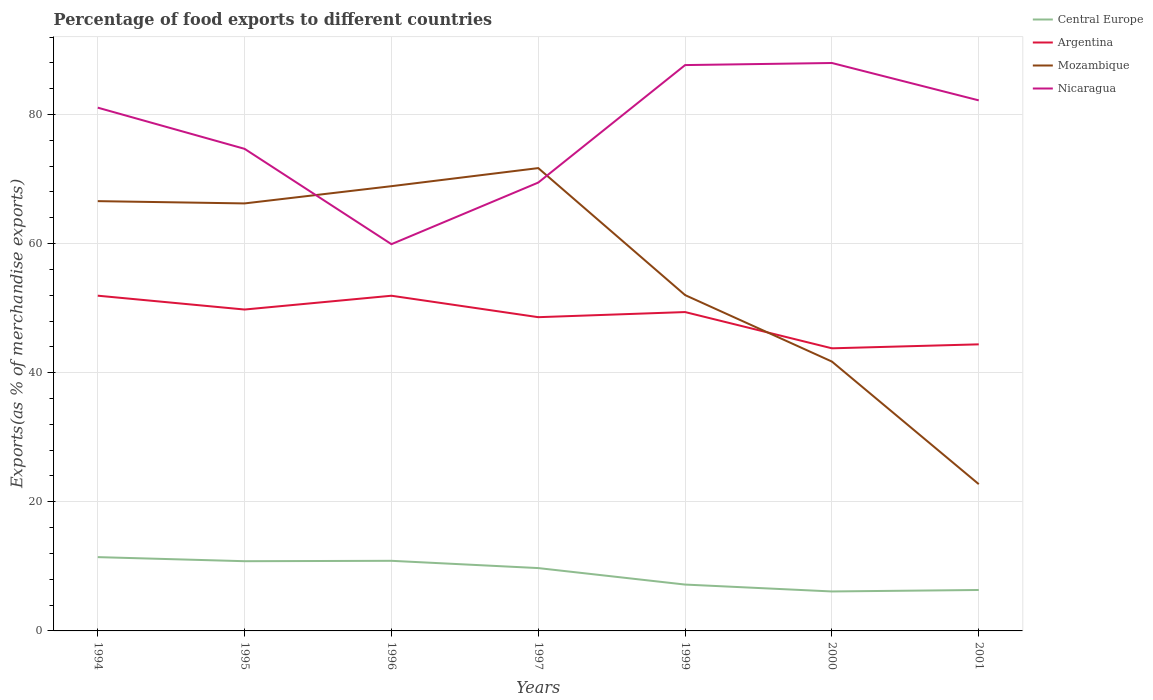How many different coloured lines are there?
Your answer should be very brief. 4. Across all years, what is the maximum percentage of exports to different countries in Mozambique?
Offer a very short reply. 22.73. In which year was the percentage of exports to different countries in Nicaragua maximum?
Offer a terse response. 1996. What is the total percentage of exports to different countries in Nicaragua in the graph?
Make the answer very short. -27.74. What is the difference between the highest and the second highest percentage of exports to different countries in Mozambique?
Your answer should be compact. 48.96. What is the difference between the highest and the lowest percentage of exports to different countries in Nicaragua?
Provide a succinct answer. 4. What is the difference between two consecutive major ticks on the Y-axis?
Ensure brevity in your answer.  20. Does the graph contain any zero values?
Keep it short and to the point. No. Does the graph contain grids?
Your answer should be compact. Yes. What is the title of the graph?
Offer a very short reply. Percentage of food exports to different countries. Does "Northern Mariana Islands" appear as one of the legend labels in the graph?
Ensure brevity in your answer.  No. What is the label or title of the Y-axis?
Offer a very short reply. Exports(as % of merchandise exports). What is the Exports(as % of merchandise exports) of Central Europe in 1994?
Your answer should be compact. 11.43. What is the Exports(as % of merchandise exports) in Argentina in 1994?
Keep it short and to the point. 51.93. What is the Exports(as % of merchandise exports) in Mozambique in 1994?
Offer a terse response. 66.58. What is the Exports(as % of merchandise exports) in Nicaragua in 1994?
Offer a very short reply. 81.06. What is the Exports(as % of merchandise exports) in Central Europe in 1995?
Provide a short and direct response. 10.8. What is the Exports(as % of merchandise exports) of Argentina in 1995?
Your response must be concise. 49.79. What is the Exports(as % of merchandise exports) in Mozambique in 1995?
Your response must be concise. 66.22. What is the Exports(as % of merchandise exports) in Nicaragua in 1995?
Offer a terse response. 74.68. What is the Exports(as % of merchandise exports) in Central Europe in 1996?
Give a very brief answer. 10.86. What is the Exports(as % of merchandise exports) in Argentina in 1996?
Make the answer very short. 51.92. What is the Exports(as % of merchandise exports) in Mozambique in 1996?
Ensure brevity in your answer.  68.89. What is the Exports(as % of merchandise exports) in Nicaragua in 1996?
Your answer should be compact. 59.91. What is the Exports(as % of merchandise exports) in Central Europe in 1997?
Your answer should be compact. 9.73. What is the Exports(as % of merchandise exports) of Argentina in 1997?
Your response must be concise. 48.6. What is the Exports(as % of merchandise exports) in Mozambique in 1997?
Make the answer very short. 71.69. What is the Exports(as % of merchandise exports) in Nicaragua in 1997?
Your answer should be very brief. 69.45. What is the Exports(as % of merchandise exports) in Central Europe in 1999?
Offer a terse response. 7.18. What is the Exports(as % of merchandise exports) of Argentina in 1999?
Provide a short and direct response. 49.39. What is the Exports(as % of merchandise exports) in Mozambique in 1999?
Your response must be concise. 52.02. What is the Exports(as % of merchandise exports) in Nicaragua in 1999?
Your answer should be very brief. 87.65. What is the Exports(as % of merchandise exports) of Central Europe in 2000?
Give a very brief answer. 6.11. What is the Exports(as % of merchandise exports) in Argentina in 2000?
Offer a very short reply. 43.78. What is the Exports(as % of merchandise exports) of Mozambique in 2000?
Keep it short and to the point. 41.72. What is the Exports(as % of merchandise exports) in Nicaragua in 2000?
Your response must be concise. 87.98. What is the Exports(as % of merchandise exports) in Central Europe in 2001?
Your answer should be compact. 6.34. What is the Exports(as % of merchandise exports) of Argentina in 2001?
Give a very brief answer. 44.39. What is the Exports(as % of merchandise exports) in Mozambique in 2001?
Your response must be concise. 22.73. What is the Exports(as % of merchandise exports) in Nicaragua in 2001?
Ensure brevity in your answer.  82.19. Across all years, what is the maximum Exports(as % of merchandise exports) in Central Europe?
Make the answer very short. 11.43. Across all years, what is the maximum Exports(as % of merchandise exports) of Argentina?
Make the answer very short. 51.93. Across all years, what is the maximum Exports(as % of merchandise exports) of Mozambique?
Your response must be concise. 71.69. Across all years, what is the maximum Exports(as % of merchandise exports) of Nicaragua?
Your response must be concise. 87.98. Across all years, what is the minimum Exports(as % of merchandise exports) in Central Europe?
Offer a terse response. 6.11. Across all years, what is the minimum Exports(as % of merchandise exports) of Argentina?
Provide a succinct answer. 43.78. Across all years, what is the minimum Exports(as % of merchandise exports) of Mozambique?
Your answer should be very brief. 22.73. Across all years, what is the minimum Exports(as % of merchandise exports) in Nicaragua?
Your answer should be compact. 59.91. What is the total Exports(as % of merchandise exports) in Central Europe in the graph?
Provide a short and direct response. 62.46. What is the total Exports(as % of merchandise exports) in Argentina in the graph?
Offer a very short reply. 339.8. What is the total Exports(as % of merchandise exports) in Mozambique in the graph?
Ensure brevity in your answer.  389.87. What is the total Exports(as % of merchandise exports) of Nicaragua in the graph?
Offer a very short reply. 542.91. What is the difference between the Exports(as % of merchandise exports) in Central Europe in 1994 and that in 1995?
Offer a terse response. 0.63. What is the difference between the Exports(as % of merchandise exports) in Argentina in 1994 and that in 1995?
Keep it short and to the point. 2.14. What is the difference between the Exports(as % of merchandise exports) in Mozambique in 1994 and that in 1995?
Your answer should be compact. 0.35. What is the difference between the Exports(as % of merchandise exports) in Nicaragua in 1994 and that in 1995?
Provide a succinct answer. 6.38. What is the difference between the Exports(as % of merchandise exports) in Central Europe in 1994 and that in 1996?
Provide a short and direct response. 0.57. What is the difference between the Exports(as % of merchandise exports) in Argentina in 1994 and that in 1996?
Your answer should be very brief. 0.01. What is the difference between the Exports(as % of merchandise exports) in Mozambique in 1994 and that in 1996?
Make the answer very short. -2.32. What is the difference between the Exports(as % of merchandise exports) in Nicaragua in 1994 and that in 1996?
Give a very brief answer. 21.15. What is the difference between the Exports(as % of merchandise exports) in Central Europe in 1994 and that in 1997?
Ensure brevity in your answer.  1.7. What is the difference between the Exports(as % of merchandise exports) of Argentina in 1994 and that in 1997?
Provide a short and direct response. 3.33. What is the difference between the Exports(as % of merchandise exports) in Mozambique in 1994 and that in 1997?
Provide a succinct answer. -5.12. What is the difference between the Exports(as % of merchandise exports) of Nicaragua in 1994 and that in 1997?
Offer a very short reply. 11.6. What is the difference between the Exports(as % of merchandise exports) of Central Europe in 1994 and that in 1999?
Provide a short and direct response. 4.25. What is the difference between the Exports(as % of merchandise exports) of Argentina in 1994 and that in 1999?
Provide a short and direct response. 2.54. What is the difference between the Exports(as % of merchandise exports) of Mozambique in 1994 and that in 1999?
Provide a succinct answer. 14.55. What is the difference between the Exports(as % of merchandise exports) of Nicaragua in 1994 and that in 1999?
Your answer should be compact. -6.6. What is the difference between the Exports(as % of merchandise exports) in Central Europe in 1994 and that in 2000?
Give a very brief answer. 5.32. What is the difference between the Exports(as % of merchandise exports) of Argentina in 1994 and that in 2000?
Ensure brevity in your answer.  8.15. What is the difference between the Exports(as % of merchandise exports) in Mozambique in 1994 and that in 2000?
Offer a very short reply. 24.85. What is the difference between the Exports(as % of merchandise exports) in Nicaragua in 1994 and that in 2000?
Offer a terse response. -6.92. What is the difference between the Exports(as % of merchandise exports) of Central Europe in 1994 and that in 2001?
Provide a succinct answer. 5.09. What is the difference between the Exports(as % of merchandise exports) of Argentina in 1994 and that in 2001?
Offer a terse response. 7.54. What is the difference between the Exports(as % of merchandise exports) of Mozambique in 1994 and that in 2001?
Offer a terse response. 43.84. What is the difference between the Exports(as % of merchandise exports) in Nicaragua in 1994 and that in 2001?
Your response must be concise. -1.13. What is the difference between the Exports(as % of merchandise exports) in Central Europe in 1995 and that in 1996?
Offer a very short reply. -0.06. What is the difference between the Exports(as % of merchandise exports) in Argentina in 1995 and that in 1996?
Provide a short and direct response. -2.14. What is the difference between the Exports(as % of merchandise exports) in Mozambique in 1995 and that in 1996?
Offer a terse response. -2.67. What is the difference between the Exports(as % of merchandise exports) in Nicaragua in 1995 and that in 1996?
Your answer should be very brief. 14.77. What is the difference between the Exports(as % of merchandise exports) in Central Europe in 1995 and that in 1997?
Give a very brief answer. 1.07. What is the difference between the Exports(as % of merchandise exports) in Argentina in 1995 and that in 1997?
Ensure brevity in your answer.  1.19. What is the difference between the Exports(as % of merchandise exports) of Mozambique in 1995 and that in 1997?
Offer a very short reply. -5.47. What is the difference between the Exports(as % of merchandise exports) in Nicaragua in 1995 and that in 1997?
Make the answer very short. 5.22. What is the difference between the Exports(as % of merchandise exports) in Central Europe in 1995 and that in 1999?
Provide a succinct answer. 3.62. What is the difference between the Exports(as % of merchandise exports) of Argentina in 1995 and that in 1999?
Keep it short and to the point. 0.39. What is the difference between the Exports(as % of merchandise exports) of Mozambique in 1995 and that in 1999?
Your answer should be compact. 14.2. What is the difference between the Exports(as % of merchandise exports) in Nicaragua in 1995 and that in 1999?
Your answer should be very brief. -12.98. What is the difference between the Exports(as % of merchandise exports) in Central Europe in 1995 and that in 2000?
Your response must be concise. 4.69. What is the difference between the Exports(as % of merchandise exports) in Argentina in 1995 and that in 2000?
Your response must be concise. 6.01. What is the difference between the Exports(as % of merchandise exports) of Mozambique in 1995 and that in 2000?
Your answer should be very brief. 24.5. What is the difference between the Exports(as % of merchandise exports) of Nicaragua in 1995 and that in 2000?
Offer a very short reply. -13.3. What is the difference between the Exports(as % of merchandise exports) of Central Europe in 1995 and that in 2001?
Your response must be concise. 4.46. What is the difference between the Exports(as % of merchandise exports) in Argentina in 1995 and that in 2001?
Give a very brief answer. 5.39. What is the difference between the Exports(as % of merchandise exports) of Mozambique in 1995 and that in 2001?
Ensure brevity in your answer.  43.49. What is the difference between the Exports(as % of merchandise exports) of Nicaragua in 1995 and that in 2001?
Keep it short and to the point. -7.51. What is the difference between the Exports(as % of merchandise exports) of Central Europe in 1996 and that in 1997?
Provide a short and direct response. 1.13. What is the difference between the Exports(as % of merchandise exports) in Argentina in 1996 and that in 1997?
Keep it short and to the point. 3.32. What is the difference between the Exports(as % of merchandise exports) of Mozambique in 1996 and that in 1997?
Offer a terse response. -2.8. What is the difference between the Exports(as % of merchandise exports) of Nicaragua in 1996 and that in 1997?
Keep it short and to the point. -9.54. What is the difference between the Exports(as % of merchandise exports) in Central Europe in 1996 and that in 1999?
Ensure brevity in your answer.  3.68. What is the difference between the Exports(as % of merchandise exports) in Argentina in 1996 and that in 1999?
Make the answer very short. 2.53. What is the difference between the Exports(as % of merchandise exports) of Mozambique in 1996 and that in 1999?
Give a very brief answer. 16.87. What is the difference between the Exports(as % of merchandise exports) in Nicaragua in 1996 and that in 1999?
Your response must be concise. -27.74. What is the difference between the Exports(as % of merchandise exports) of Central Europe in 1996 and that in 2000?
Provide a short and direct response. 4.75. What is the difference between the Exports(as % of merchandise exports) in Argentina in 1996 and that in 2000?
Provide a succinct answer. 8.14. What is the difference between the Exports(as % of merchandise exports) in Mozambique in 1996 and that in 2000?
Your response must be concise. 27.17. What is the difference between the Exports(as % of merchandise exports) in Nicaragua in 1996 and that in 2000?
Offer a very short reply. -28.07. What is the difference between the Exports(as % of merchandise exports) of Central Europe in 1996 and that in 2001?
Make the answer very short. 4.52. What is the difference between the Exports(as % of merchandise exports) of Argentina in 1996 and that in 2001?
Offer a terse response. 7.53. What is the difference between the Exports(as % of merchandise exports) of Mozambique in 1996 and that in 2001?
Keep it short and to the point. 46.16. What is the difference between the Exports(as % of merchandise exports) of Nicaragua in 1996 and that in 2001?
Ensure brevity in your answer.  -22.28. What is the difference between the Exports(as % of merchandise exports) in Central Europe in 1997 and that in 1999?
Ensure brevity in your answer.  2.55. What is the difference between the Exports(as % of merchandise exports) of Argentina in 1997 and that in 1999?
Your answer should be very brief. -0.79. What is the difference between the Exports(as % of merchandise exports) of Mozambique in 1997 and that in 1999?
Your answer should be very brief. 19.67. What is the difference between the Exports(as % of merchandise exports) of Nicaragua in 1997 and that in 1999?
Ensure brevity in your answer.  -18.2. What is the difference between the Exports(as % of merchandise exports) of Central Europe in 1997 and that in 2000?
Ensure brevity in your answer.  3.62. What is the difference between the Exports(as % of merchandise exports) of Argentina in 1997 and that in 2000?
Offer a very short reply. 4.82. What is the difference between the Exports(as % of merchandise exports) of Mozambique in 1997 and that in 2000?
Your answer should be compact. 29.97. What is the difference between the Exports(as % of merchandise exports) in Nicaragua in 1997 and that in 2000?
Ensure brevity in your answer.  -18.52. What is the difference between the Exports(as % of merchandise exports) in Central Europe in 1997 and that in 2001?
Give a very brief answer. 3.39. What is the difference between the Exports(as % of merchandise exports) of Argentina in 1997 and that in 2001?
Make the answer very short. 4.21. What is the difference between the Exports(as % of merchandise exports) of Mozambique in 1997 and that in 2001?
Make the answer very short. 48.96. What is the difference between the Exports(as % of merchandise exports) of Nicaragua in 1997 and that in 2001?
Offer a very short reply. -12.73. What is the difference between the Exports(as % of merchandise exports) of Central Europe in 1999 and that in 2000?
Your response must be concise. 1.07. What is the difference between the Exports(as % of merchandise exports) in Argentina in 1999 and that in 2000?
Your answer should be compact. 5.62. What is the difference between the Exports(as % of merchandise exports) of Mozambique in 1999 and that in 2000?
Offer a very short reply. 10.3. What is the difference between the Exports(as % of merchandise exports) of Nicaragua in 1999 and that in 2000?
Offer a terse response. -0.32. What is the difference between the Exports(as % of merchandise exports) of Central Europe in 1999 and that in 2001?
Make the answer very short. 0.84. What is the difference between the Exports(as % of merchandise exports) of Argentina in 1999 and that in 2001?
Your answer should be very brief. 5. What is the difference between the Exports(as % of merchandise exports) in Mozambique in 1999 and that in 2001?
Your response must be concise. 29.29. What is the difference between the Exports(as % of merchandise exports) of Nicaragua in 1999 and that in 2001?
Give a very brief answer. 5.47. What is the difference between the Exports(as % of merchandise exports) in Central Europe in 2000 and that in 2001?
Make the answer very short. -0.23. What is the difference between the Exports(as % of merchandise exports) in Argentina in 2000 and that in 2001?
Offer a terse response. -0.61. What is the difference between the Exports(as % of merchandise exports) in Mozambique in 2000 and that in 2001?
Your answer should be compact. 18.99. What is the difference between the Exports(as % of merchandise exports) of Nicaragua in 2000 and that in 2001?
Your answer should be compact. 5.79. What is the difference between the Exports(as % of merchandise exports) of Central Europe in 1994 and the Exports(as % of merchandise exports) of Argentina in 1995?
Your response must be concise. -38.35. What is the difference between the Exports(as % of merchandise exports) of Central Europe in 1994 and the Exports(as % of merchandise exports) of Mozambique in 1995?
Provide a succinct answer. -54.79. What is the difference between the Exports(as % of merchandise exports) of Central Europe in 1994 and the Exports(as % of merchandise exports) of Nicaragua in 1995?
Keep it short and to the point. -63.25. What is the difference between the Exports(as % of merchandise exports) of Argentina in 1994 and the Exports(as % of merchandise exports) of Mozambique in 1995?
Provide a short and direct response. -14.29. What is the difference between the Exports(as % of merchandise exports) of Argentina in 1994 and the Exports(as % of merchandise exports) of Nicaragua in 1995?
Provide a short and direct response. -22.75. What is the difference between the Exports(as % of merchandise exports) in Mozambique in 1994 and the Exports(as % of merchandise exports) in Nicaragua in 1995?
Ensure brevity in your answer.  -8.1. What is the difference between the Exports(as % of merchandise exports) in Central Europe in 1994 and the Exports(as % of merchandise exports) in Argentina in 1996?
Ensure brevity in your answer.  -40.49. What is the difference between the Exports(as % of merchandise exports) of Central Europe in 1994 and the Exports(as % of merchandise exports) of Mozambique in 1996?
Your answer should be very brief. -57.46. What is the difference between the Exports(as % of merchandise exports) in Central Europe in 1994 and the Exports(as % of merchandise exports) in Nicaragua in 1996?
Provide a succinct answer. -48.48. What is the difference between the Exports(as % of merchandise exports) in Argentina in 1994 and the Exports(as % of merchandise exports) in Mozambique in 1996?
Your response must be concise. -16.96. What is the difference between the Exports(as % of merchandise exports) of Argentina in 1994 and the Exports(as % of merchandise exports) of Nicaragua in 1996?
Offer a very short reply. -7.98. What is the difference between the Exports(as % of merchandise exports) of Mozambique in 1994 and the Exports(as % of merchandise exports) of Nicaragua in 1996?
Provide a short and direct response. 6.67. What is the difference between the Exports(as % of merchandise exports) in Central Europe in 1994 and the Exports(as % of merchandise exports) in Argentina in 1997?
Give a very brief answer. -37.17. What is the difference between the Exports(as % of merchandise exports) of Central Europe in 1994 and the Exports(as % of merchandise exports) of Mozambique in 1997?
Give a very brief answer. -60.26. What is the difference between the Exports(as % of merchandise exports) in Central Europe in 1994 and the Exports(as % of merchandise exports) in Nicaragua in 1997?
Your answer should be very brief. -58.02. What is the difference between the Exports(as % of merchandise exports) of Argentina in 1994 and the Exports(as % of merchandise exports) of Mozambique in 1997?
Offer a very short reply. -19.76. What is the difference between the Exports(as % of merchandise exports) of Argentina in 1994 and the Exports(as % of merchandise exports) of Nicaragua in 1997?
Offer a terse response. -17.52. What is the difference between the Exports(as % of merchandise exports) in Mozambique in 1994 and the Exports(as % of merchandise exports) in Nicaragua in 1997?
Give a very brief answer. -2.88. What is the difference between the Exports(as % of merchandise exports) in Central Europe in 1994 and the Exports(as % of merchandise exports) in Argentina in 1999?
Provide a short and direct response. -37.96. What is the difference between the Exports(as % of merchandise exports) of Central Europe in 1994 and the Exports(as % of merchandise exports) of Mozambique in 1999?
Provide a succinct answer. -40.59. What is the difference between the Exports(as % of merchandise exports) in Central Europe in 1994 and the Exports(as % of merchandise exports) in Nicaragua in 1999?
Your answer should be very brief. -76.22. What is the difference between the Exports(as % of merchandise exports) in Argentina in 1994 and the Exports(as % of merchandise exports) in Mozambique in 1999?
Provide a short and direct response. -0.09. What is the difference between the Exports(as % of merchandise exports) of Argentina in 1994 and the Exports(as % of merchandise exports) of Nicaragua in 1999?
Your answer should be very brief. -35.72. What is the difference between the Exports(as % of merchandise exports) of Mozambique in 1994 and the Exports(as % of merchandise exports) of Nicaragua in 1999?
Your answer should be very brief. -21.08. What is the difference between the Exports(as % of merchandise exports) of Central Europe in 1994 and the Exports(as % of merchandise exports) of Argentina in 2000?
Give a very brief answer. -32.35. What is the difference between the Exports(as % of merchandise exports) of Central Europe in 1994 and the Exports(as % of merchandise exports) of Mozambique in 2000?
Offer a very short reply. -30.29. What is the difference between the Exports(as % of merchandise exports) of Central Europe in 1994 and the Exports(as % of merchandise exports) of Nicaragua in 2000?
Ensure brevity in your answer.  -76.54. What is the difference between the Exports(as % of merchandise exports) in Argentina in 1994 and the Exports(as % of merchandise exports) in Mozambique in 2000?
Your response must be concise. 10.21. What is the difference between the Exports(as % of merchandise exports) in Argentina in 1994 and the Exports(as % of merchandise exports) in Nicaragua in 2000?
Offer a terse response. -36.04. What is the difference between the Exports(as % of merchandise exports) of Mozambique in 1994 and the Exports(as % of merchandise exports) of Nicaragua in 2000?
Give a very brief answer. -21.4. What is the difference between the Exports(as % of merchandise exports) of Central Europe in 1994 and the Exports(as % of merchandise exports) of Argentina in 2001?
Your answer should be very brief. -32.96. What is the difference between the Exports(as % of merchandise exports) in Central Europe in 1994 and the Exports(as % of merchandise exports) in Mozambique in 2001?
Give a very brief answer. -11.3. What is the difference between the Exports(as % of merchandise exports) of Central Europe in 1994 and the Exports(as % of merchandise exports) of Nicaragua in 2001?
Ensure brevity in your answer.  -70.75. What is the difference between the Exports(as % of merchandise exports) in Argentina in 1994 and the Exports(as % of merchandise exports) in Mozambique in 2001?
Provide a short and direct response. 29.2. What is the difference between the Exports(as % of merchandise exports) of Argentina in 1994 and the Exports(as % of merchandise exports) of Nicaragua in 2001?
Provide a succinct answer. -30.26. What is the difference between the Exports(as % of merchandise exports) in Mozambique in 1994 and the Exports(as % of merchandise exports) in Nicaragua in 2001?
Your answer should be very brief. -15.61. What is the difference between the Exports(as % of merchandise exports) of Central Europe in 1995 and the Exports(as % of merchandise exports) of Argentina in 1996?
Offer a terse response. -41.12. What is the difference between the Exports(as % of merchandise exports) in Central Europe in 1995 and the Exports(as % of merchandise exports) in Mozambique in 1996?
Your answer should be compact. -58.09. What is the difference between the Exports(as % of merchandise exports) of Central Europe in 1995 and the Exports(as % of merchandise exports) of Nicaragua in 1996?
Provide a short and direct response. -49.11. What is the difference between the Exports(as % of merchandise exports) in Argentina in 1995 and the Exports(as % of merchandise exports) in Mozambique in 1996?
Make the answer very short. -19.11. What is the difference between the Exports(as % of merchandise exports) in Argentina in 1995 and the Exports(as % of merchandise exports) in Nicaragua in 1996?
Your answer should be very brief. -10.12. What is the difference between the Exports(as % of merchandise exports) in Mozambique in 1995 and the Exports(as % of merchandise exports) in Nicaragua in 1996?
Give a very brief answer. 6.31. What is the difference between the Exports(as % of merchandise exports) of Central Europe in 1995 and the Exports(as % of merchandise exports) of Argentina in 1997?
Give a very brief answer. -37.8. What is the difference between the Exports(as % of merchandise exports) of Central Europe in 1995 and the Exports(as % of merchandise exports) of Mozambique in 1997?
Give a very brief answer. -60.89. What is the difference between the Exports(as % of merchandise exports) in Central Europe in 1995 and the Exports(as % of merchandise exports) in Nicaragua in 1997?
Provide a short and direct response. -58.65. What is the difference between the Exports(as % of merchandise exports) of Argentina in 1995 and the Exports(as % of merchandise exports) of Mozambique in 1997?
Make the answer very short. -21.91. What is the difference between the Exports(as % of merchandise exports) of Argentina in 1995 and the Exports(as % of merchandise exports) of Nicaragua in 1997?
Make the answer very short. -19.67. What is the difference between the Exports(as % of merchandise exports) of Mozambique in 1995 and the Exports(as % of merchandise exports) of Nicaragua in 1997?
Give a very brief answer. -3.23. What is the difference between the Exports(as % of merchandise exports) in Central Europe in 1995 and the Exports(as % of merchandise exports) in Argentina in 1999?
Provide a succinct answer. -38.59. What is the difference between the Exports(as % of merchandise exports) in Central Europe in 1995 and the Exports(as % of merchandise exports) in Mozambique in 1999?
Your response must be concise. -41.22. What is the difference between the Exports(as % of merchandise exports) of Central Europe in 1995 and the Exports(as % of merchandise exports) of Nicaragua in 1999?
Your response must be concise. -76.85. What is the difference between the Exports(as % of merchandise exports) of Argentina in 1995 and the Exports(as % of merchandise exports) of Mozambique in 1999?
Provide a short and direct response. -2.24. What is the difference between the Exports(as % of merchandise exports) of Argentina in 1995 and the Exports(as % of merchandise exports) of Nicaragua in 1999?
Provide a succinct answer. -37.87. What is the difference between the Exports(as % of merchandise exports) of Mozambique in 1995 and the Exports(as % of merchandise exports) of Nicaragua in 1999?
Offer a very short reply. -21.43. What is the difference between the Exports(as % of merchandise exports) in Central Europe in 1995 and the Exports(as % of merchandise exports) in Argentina in 2000?
Your answer should be compact. -32.98. What is the difference between the Exports(as % of merchandise exports) of Central Europe in 1995 and the Exports(as % of merchandise exports) of Mozambique in 2000?
Keep it short and to the point. -30.92. What is the difference between the Exports(as % of merchandise exports) in Central Europe in 1995 and the Exports(as % of merchandise exports) in Nicaragua in 2000?
Give a very brief answer. -77.18. What is the difference between the Exports(as % of merchandise exports) in Argentina in 1995 and the Exports(as % of merchandise exports) in Mozambique in 2000?
Offer a terse response. 8.06. What is the difference between the Exports(as % of merchandise exports) of Argentina in 1995 and the Exports(as % of merchandise exports) of Nicaragua in 2000?
Provide a short and direct response. -38.19. What is the difference between the Exports(as % of merchandise exports) of Mozambique in 1995 and the Exports(as % of merchandise exports) of Nicaragua in 2000?
Make the answer very short. -21.75. What is the difference between the Exports(as % of merchandise exports) in Central Europe in 1995 and the Exports(as % of merchandise exports) in Argentina in 2001?
Keep it short and to the point. -33.59. What is the difference between the Exports(as % of merchandise exports) of Central Europe in 1995 and the Exports(as % of merchandise exports) of Mozambique in 2001?
Your answer should be very brief. -11.94. What is the difference between the Exports(as % of merchandise exports) in Central Europe in 1995 and the Exports(as % of merchandise exports) in Nicaragua in 2001?
Offer a terse response. -71.39. What is the difference between the Exports(as % of merchandise exports) of Argentina in 1995 and the Exports(as % of merchandise exports) of Mozambique in 2001?
Keep it short and to the point. 27.05. What is the difference between the Exports(as % of merchandise exports) in Argentina in 1995 and the Exports(as % of merchandise exports) in Nicaragua in 2001?
Offer a very short reply. -32.4. What is the difference between the Exports(as % of merchandise exports) in Mozambique in 1995 and the Exports(as % of merchandise exports) in Nicaragua in 2001?
Offer a very short reply. -15.96. What is the difference between the Exports(as % of merchandise exports) in Central Europe in 1996 and the Exports(as % of merchandise exports) in Argentina in 1997?
Offer a very short reply. -37.74. What is the difference between the Exports(as % of merchandise exports) in Central Europe in 1996 and the Exports(as % of merchandise exports) in Mozambique in 1997?
Your answer should be compact. -60.83. What is the difference between the Exports(as % of merchandise exports) of Central Europe in 1996 and the Exports(as % of merchandise exports) of Nicaragua in 1997?
Make the answer very short. -58.59. What is the difference between the Exports(as % of merchandise exports) in Argentina in 1996 and the Exports(as % of merchandise exports) in Mozambique in 1997?
Ensure brevity in your answer.  -19.77. What is the difference between the Exports(as % of merchandise exports) of Argentina in 1996 and the Exports(as % of merchandise exports) of Nicaragua in 1997?
Your response must be concise. -17.53. What is the difference between the Exports(as % of merchandise exports) of Mozambique in 1996 and the Exports(as % of merchandise exports) of Nicaragua in 1997?
Your answer should be very brief. -0.56. What is the difference between the Exports(as % of merchandise exports) of Central Europe in 1996 and the Exports(as % of merchandise exports) of Argentina in 1999?
Make the answer very short. -38.53. What is the difference between the Exports(as % of merchandise exports) in Central Europe in 1996 and the Exports(as % of merchandise exports) in Mozambique in 1999?
Provide a succinct answer. -41.16. What is the difference between the Exports(as % of merchandise exports) in Central Europe in 1996 and the Exports(as % of merchandise exports) in Nicaragua in 1999?
Your answer should be very brief. -76.79. What is the difference between the Exports(as % of merchandise exports) in Argentina in 1996 and the Exports(as % of merchandise exports) in Mozambique in 1999?
Give a very brief answer. -0.1. What is the difference between the Exports(as % of merchandise exports) of Argentina in 1996 and the Exports(as % of merchandise exports) of Nicaragua in 1999?
Make the answer very short. -35.73. What is the difference between the Exports(as % of merchandise exports) in Mozambique in 1996 and the Exports(as % of merchandise exports) in Nicaragua in 1999?
Offer a terse response. -18.76. What is the difference between the Exports(as % of merchandise exports) in Central Europe in 1996 and the Exports(as % of merchandise exports) in Argentina in 2000?
Ensure brevity in your answer.  -32.92. What is the difference between the Exports(as % of merchandise exports) of Central Europe in 1996 and the Exports(as % of merchandise exports) of Mozambique in 2000?
Provide a short and direct response. -30.86. What is the difference between the Exports(as % of merchandise exports) in Central Europe in 1996 and the Exports(as % of merchandise exports) in Nicaragua in 2000?
Ensure brevity in your answer.  -77.12. What is the difference between the Exports(as % of merchandise exports) of Argentina in 1996 and the Exports(as % of merchandise exports) of Mozambique in 2000?
Your response must be concise. 10.2. What is the difference between the Exports(as % of merchandise exports) of Argentina in 1996 and the Exports(as % of merchandise exports) of Nicaragua in 2000?
Make the answer very short. -36.05. What is the difference between the Exports(as % of merchandise exports) in Mozambique in 1996 and the Exports(as % of merchandise exports) in Nicaragua in 2000?
Offer a very short reply. -19.08. What is the difference between the Exports(as % of merchandise exports) in Central Europe in 1996 and the Exports(as % of merchandise exports) in Argentina in 2001?
Your response must be concise. -33.53. What is the difference between the Exports(as % of merchandise exports) in Central Europe in 1996 and the Exports(as % of merchandise exports) in Mozambique in 2001?
Give a very brief answer. -11.88. What is the difference between the Exports(as % of merchandise exports) of Central Europe in 1996 and the Exports(as % of merchandise exports) of Nicaragua in 2001?
Offer a very short reply. -71.33. What is the difference between the Exports(as % of merchandise exports) of Argentina in 1996 and the Exports(as % of merchandise exports) of Mozambique in 2001?
Your answer should be compact. 29.19. What is the difference between the Exports(as % of merchandise exports) of Argentina in 1996 and the Exports(as % of merchandise exports) of Nicaragua in 2001?
Provide a short and direct response. -30.26. What is the difference between the Exports(as % of merchandise exports) in Mozambique in 1996 and the Exports(as % of merchandise exports) in Nicaragua in 2001?
Offer a terse response. -13.29. What is the difference between the Exports(as % of merchandise exports) of Central Europe in 1997 and the Exports(as % of merchandise exports) of Argentina in 1999?
Offer a very short reply. -39.66. What is the difference between the Exports(as % of merchandise exports) of Central Europe in 1997 and the Exports(as % of merchandise exports) of Mozambique in 1999?
Your response must be concise. -42.29. What is the difference between the Exports(as % of merchandise exports) of Central Europe in 1997 and the Exports(as % of merchandise exports) of Nicaragua in 1999?
Offer a very short reply. -77.92. What is the difference between the Exports(as % of merchandise exports) in Argentina in 1997 and the Exports(as % of merchandise exports) in Mozambique in 1999?
Your response must be concise. -3.42. What is the difference between the Exports(as % of merchandise exports) of Argentina in 1997 and the Exports(as % of merchandise exports) of Nicaragua in 1999?
Make the answer very short. -39.05. What is the difference between the Exports(as % of merchandise exports) in Mozambique in 1997 and the Exports(as % of merchandise exports) in Nicaragua in 1999?
Your response must be concise. -15.96. What is the difference between the Exports(as % of merchandise exports) in Central Europe in 1997 and the Exports(as % of merchandise exports) in Argentina in 2000?
Your answer should be very brief. -34.04. What is the difference between the Exports(as % of merchandise exports) in Central Europe in 1997 and the Exports(as % of merchandise exports) in Mozambique in 2000?
Your response must be concise. -31.99. What is the difference between the Exports(as % of merchandise exports) of Central Europe in 1997 and the Exports(as % of merchandise exports) of Nicaragua in 2000?
Provide a succinct answer. -78.24. What is the difference between the Exports(as % of merchandise exports) of Argentina in 1997 and the Exports(as % of merchandise exports) of Mozambique in 2000?
Give a very brief answer. 6.88. What is the difference between the Exports(as % of merchandise exports) of Argentina in 1997 and the Exports(as % of merchandise exports) of Nicaragua in 2000?
Give a very brief answer. -39.37. What is the difference between the Exports(as % of merchandise exports) of Mozambique in 1997 and the Exports(as % of merchandise exports) of Nicaragua in 2000?
Provide a succinct answer. -16.28. What is the difference between the Exports(as % of merchandise exports) in Central Europe in 1997 and the Exports(as % of merchandise exports) in Argentina in 2001?
Your answer should be compact. -34.66. What is the difference between the Exports(as % of merchandise exports) in Central Europe in 1997 and the Exports(as % of merchandise exports) in Mozambique in 2001?
Ensure brevity in your answer.  -13. What is the difference between the Exports(as % of merchandise exports) in Central Europe in 1997 and the Exports(as % of merchandise exports) in Nicaragua in 2001?
Give a very brief answer. -72.45. What is the difference between the Exports(as % of merchandise exports) of Argentina in 1997 and the Exports(as % of merchandise exports) of Mozambique in 2001?
Your response must be concise. 25.87. What is the difference between the Exports(as % of merchandise exports) in Argentina in 1997 and the Exports(as % of merchandise exports) in Nicaragua in 2001?
Keep it short and to the point. -33.58. What is the difference between the Exports(as % of merchandise exports) of Mozambique in 1997 and the Exports(as % of merchandise exports) of Nicaragua in 2001?
Provide a short and direct response. -10.49. What is the difference between the Exports(as % of merchandise exports) of Central Europe in 1999 and the Exports(as % of merchandise exports) of Argentina in 2000?
Offer a terse response. -36.6. What is the difference between the Exports(as % of merchandise exports) of Central Europe in 1999 and the Exports(as % of merchandise exports) of Mozambique in 2000?
Make the answer very short. -34.54. What is the difference between the Exports(as % of merchandise exports) in Central Europe in 1999 and the Exports(as % of merchandise exports) in Nicaragua in 2000?
Ensure brevity in your answer.  -80.79. What is the difference between the Exports(as % of merchandise exports) in Argentina in 1999 and the Exports(as % of merchandise exports) in Mozambique in 2000?
Give a very brief answer. 7.67. What is the difference between the Exports(as % of merchandise exports) of Argentina in 1999 and the Exports(as % of merchandise exports) of Nicaragua in 2000?
Your answer should be very brief. -38.58. What is the difference between the Exports(as % of merchandise exports) in Mozambique in 1999 and the Exports(as % of merchandise exports) in Nicaragua in 2000?
Keep it short and to the point. -35.95. What is the difference between the Exports(as % of merchandise exports) in Central Europe in 1999 and the Exports(as % of merchandise exports) in Argentina in 2001?
Keep it short and to the point. -37.21. What is the difference between the Exports(as % of merchandise exports) of Central Europe in 1999 and the Exports(as % of merchandise exports) of Mozambique in 2001?
Your answer should be very brief. -15.55. What is the difference between the Exports(as % of merchandise exports) in Central Europe in 1999 and the Exports(as % of merchandise exports) in Nicaragua in 2001?
Offer a terse response. -75. What is the difference between the Exports(as % of merchandise exports) of Argentina in 1999 and the Exports(as % of merchandise exports) of Mozambique in 2001?
Make the answer very short. 26.66. What is the difference between the Exports(as % of merchandise exports) in Argentina in 1999 and the Exports(as % of merchandise exports) in Nicaragua in 2001?
Your answer should be compact. -32.79. What is the difference between the Exports(as % of merchandise exports) in Mozambique in 1999 and the Exports(as % of merchandise exports) in Nicaragua in 2001?
Keep it short and to the point. -30.16. What is the difference between the Exports(as % of merchandise exports) in Central Europe in 2000 and the Exports(as % of merchandise exports) in Argentina in 2001?
Your answer should be compact. -38.28. What is the difference between the Exports(as % of merchandise exports) of Central Europe in 2000 and the Exports(as % of merchandise exports) of Mozambique in 2001?
Your response must be concise. -16.62. What is the difference between the Exports(as % of merchandise exports) in Central Europe in 2000 and the Exports(as % of merchandise exports) in Nicaragua in 2001?
Offer a very short reply. -76.07. What is the difference between the Exports(as % of merchandise exports) of Argentina in 2000 and the Exports(as % of merchandise exports) of Mozambique in 2001?
Provide a succinct answer. 21.04. What is the difference between the Exports(as % of merchandise exports) in Argentina in 2000 and the Exports(as % of merchandise exports) in Nicaragua in 2001?
Your answer should be compact. -38.41. What is the difference between the Exports(as % of merchandise exports) of Mozambique in 2000 and the Exports(as % of merchandise exports) of Nicaragua in 2001?
Provide a succinct answer. -40.46. What is the average Exports(as % of merchandise exports) of Central Europe per year?
Ensure brevity in your answer.  8.92. What is the average Exports(as % of merchandise exports) in Argentina per year?
Your response must be concise. 48.54. What is the average Exports(as % of merchandise exports) in Mozambique per year?
Make the answer very short. 55.7. What is the average Exports(as % of merchandise exports) in Nicaragua per year?
Your answer should be very brief. 77.56. In the year 1994, what is the difference between the Exports(as % of merchandise exports) of Central Europe and Exports(as % of merchandise exports) of Argentina?
Offer a very short reply. -40.5. In the year 1994, what is the difference between the Exports(as % of merchandise exports) in Central Europe and Exports(as % of merchandise exports) in Mozambique?
Ensure brevity in your answer.  -55.15. In the year 1994, what is the difference between the Exports(as % of merchandise exports) in Central Europe and Exports(as % of merchandise exports) in Nicaragua?
Your answer should be compact. -69.63. In the year 1994, what is the difference between the Exports(as % of merchandise exports) of Argentina and Exports(as % of merchandise exports) of Mozambique?
Offer a very short reply. -14.65. In the year 1994, what is the difference between the Exports(as % of merchandise exports) of Argentina and Exports(as % of merchandise exports) of Nicaragua?
Offer a terse response. -29.13. In the year 1994, what is the difference between the Exports(as % of merchandise exports) of Mozambique and Exports(as % of merchandise exports) of Nicaragua?
Your answer should be compact. -14.48. In the year 1995, what is the difference between the Exports(as % of merchandise exports) of Central Europe and Exports(as % of merchandise exports) of Argentina?
Provide a short and direct response. -38.99. In the year 1995, what is the difference between the Exports(as % of merchandise exports) in Central Europe and Exports(as % of merchandise exports) in Mozambique?
Ensure brevity in your answer.  -55.42. In the year 1995, what is the difference between the Exports(as % of merchandise exports) in Central Europe and Exports(as % of merchandise exports) in Nicaragua?
Provide a short and direct response. -63.88. In the year 1995, what is the difference between the Exports(as % of merchandise exports) of Argentina and Exports(as % of merchandise exports) of Mozambique?
Your answer should be compact. -16.44. In the year 1995, what is the difference between the Exports(as % of merchandise exports) of Argentina and Exports(as % of merchandise exports) of Nicaragua?
Provide a short and direct response. -24.89. In the year 1995, what is the difference between the Exports(as % of merchandise exports) of Mozambique and Exports(as % of merchandise exports) of Nicaragua?
Your response must be concise. -8.45. In the year 1996, what is the difference between the Exports(as % of merchandise exports) in Central Europe and Exports(as % of merchandise exports) in Argentina?
Make the answer very short. -41.06. In the year 1996, what is the difference between the Exports(as % of merchandise exports) of Central Europe and Exports(as % of merchandise exports) of Mozambique?
Your answer should be compact. -58.03. In the year 1996, what is the difference between the Exports(as % of merchandise exports) of Central Europe and Exports(as % of merchandise exports) of Nicaragua?
Keep it short and to the point. -49.05. In the year 1996, what is the difference between the Exports(as % of merchandise exports) in Argentina and Exports(as % of merchandise exports) in Mozambique?
Keep it short and to the point. -16.97. In the year 1996, what is the difference between the Exports(as % of merchandise exports) of Argentina and Exports(as % of merchandise exports) of Nicaragua?
Your answer should be compact. -7.99. In the year 1996, what is the difference between the Exports(as % of merchandise exports) of Mozambique and Exports(as % of merchandise exports) of Nicaragua?
Keep it short and to the point. 8.98. In the year 1997, what is the difference between the Exports(as % of merchandise exports) in Central Europe and Exports(as % of merchandise exports) in Argentina?
Provide a short and direct response. -38.87. In the year 1997, what is the difference between the Exports(as % of merchandise exports) of Central Europe and Exports(as % of merchandise exports) of Mozambique?
Keep it short and to the point. -61.96. In the year 1997, what is the difference between the Exports(as % of merchandise exports) in Central Europe and Exports(as % of merchandise exports) in Nicaragua?
Make the answer very short. -59.72. In the year 1997, what is the difference between the Exports(as % of merchandise exports) in Argentina and Exports(as % of merchandise exports) in Mozambique?
Offer a terse response. -23.09. In the year 1997, what is the difference between the Exports(as % of merchandise exports) in Argentina and Exports(as % of merchandise exports) in Nicaragua?
Provide a succinct answer. -20.85. In the year 1997, what is the difference between the Exports(as % of merchandise exports) in Mozambique and Exports(as % of merchandise exports) in Nicaragua?
Provide a succinct answer. 2.24. In the year 1999, what is the difference between the Exports(as % of merchandise exports) in Central Europe and Exports(as % of merchandise exports) in Argentina?
Ensure brevity in your answer.  -42.21. In the year 1999, what is the difference between the Exports(as % of merchandise exports) in Central Europe and Exports(as % of merchandise exports) in Mozambique?
Your answer should be very brief. -44.84. In the year 1999, what is the difference between the Exports(as % of merchandise exports) of Central Europe and Exports(as % of merchandise exports) of Nicaragua?
Offer a terse response. -80.47. In the year 1999, what is the difference between the Exports(as % of merchandise exports) in Argentina and Exports(as % of merchandise exports) in Mozambique?
Your answer should be very brief. -2.63. In the year 1999, what is the difference between the Exports(as % of merchandise exports) in Argentina and Exports(as % of merchandise exports) in Nicaragua?
Make the answer very short. -38.26. In the year 1999, what is the difference between the Exports(as % of merchandise exports) in Mozambique and Exports(as % of merchandise exports) in Nicaragua?
Your answer should be very brief. -35.63. In the year 2000, what is the difference between the Exports(as % of merchandise exports) of Central Europe and Exports(as % of merchandise exports) of Argentina?
Provide a succinct answer. -37.67. In the year 2000, what is the difference between the Exports(as % of merchandise exports) of Central Europe and Exports(as % of merchandise exports) of Mozambique?
Your answer should be very brief. -35.61. In the year 2000, what is the difference between the Exports(as % of merchandise exports) of Central Europe and Exports(as % of merchandise exports) of Nicaragua?
Give a very brief answer. -81.86. In the year 2000, what is the difference between the Exports(as % of merchandise exports) in Argentina and Exports(as % of merchandise exports) in Mozambique?
Ensure brevity in your answer.  2.06. In the year 2000, what is the difference between the Exports(as % of merchandise exports) of Argentina and Exports(as % of merchandise exports) of Nicaragua?
Your answer should be compact. -44.2. In the year 2000, what is the difference between the Exports(as % of merchandise exports) in Mozambique and Exports(as % of merchandise exports) in Nicaragua?
Your response must be concise. -46.25. In the year 2001, what is the difference between the Exports(as % of merchandise exports) of Central Europe and Exports(as % of merchandise exports) of Argentina?
Your answer should be compact. -38.05. In the year 2001, what is the difference between the Exports(as % of merchandise exports) in Central Europe and Exports(as % of merchandise exports) in Mozambique?
Your answer should be very brief. -16.39. In the year 2001, what is the difference between the Exports(as % of merchandise exports) of Central Europe and Exports(as % of merchandise exports) of Nicaragua?
Your answer should be very brief. -75.84. In the year 2001, what is the difference between the Exports(as % of merchandise exports) in Argentina and Exports(as % of merchandise exports) in Mozambique?
Make the answer very short. 21.66. In the year 2001, what is the difference between the Exports(as % of merchandise exports) in Argentina and Exports(as % of merchandise exports) in Nicaragua?
Your answer should be very brief. -37.79. In the year 2001, what is the difference between the Exports(as % of merchandise exports) of Mozambique and Exports(as % of merchandise exports) of Nicaragua?
Provide a short and direct response. -59.45. What is the ratio of the Exports(as % of merchandise exports) in Central Europe in 1994 to that in 1995?
Your answer should be compact. 1.06. What is the ratio of the Exports(as % of merchandise exports) in Argentina in 1994 to that in 1995?
Provide a short and direct response. 1.04. What is the ratio of the Exports(as % of merchandise exports) of Nicaragua in 1994 to that in 1995?
Ensure brevity in your answer.  1.09. What is the ratio of the Exports(as % of merchandise exports) in Central Europe in 1994 to that in 1996?
Provide a short and direct response. 1.05. What is the ratio of the Exports(as % of merchandise exports) in Mozambique in 1994 to that in 1996?
Provide a short and direct response. 0.97. What is the ratio of the Exports(as % of merchandise exports) of Nicaragua in 1994 to that in 1996?
Your answer should be compact. 1.35. What is the ratio of the Exports(as % of merchandise exports) of Central Europe in 1994 to that in 1997?
Provide a short and direct response. 1.17. What is the ratio of the Exports(as % of merchandise exports) in Argentina in 1994 to that in 1997?
Give a very brief answer. 1.07. What is the ratio of the Exports(as % of merchandise exports) of Mozambique in 1994 to that in 1997?
Provide a short and direct response. 0.93. What is the ratio of the Exports(as % of merchandise exports) in Nicaragua in 1994 to that in 1997?
Provide a short and direct response. 1.17. What is the ratio of the Exports(as % of merchandise exports) in Central Europe in 1994 to that in 1999?
Your answer should be very brief. 1.59. What is the ratio of the Exports(as % of merchandise exports) in Argentina in 1994 to that in 1999?
Offer a terse response. 1.05. What is the ratio of the Exports(as % of merchandise exports) in Mozambique in 1994 to that in 1999?
Make the answer very short. 1.28. What is the ratio of the Exports(as % of merchandise exports) of Nicaragua in 1994 to that in 1999?
Provide a succinct answer. 0.92. What is the ratio of the Exports(as % of merchandise exports) in Central Europe in 1994 to that in 2000?
Make the answer very short. 1.87. What is the ratio of the Exports(as % of merchandise exports) of Argentina in 1994 to that in 2000?
Make the answer very short. 1.19. What is the ratio of the Exports(as % of merchandise exports) in Mozambique in 1994 to that in 2000?
Keep it short and to the point. 1.6. What is the ratio of the Exports(as % of merchandise exports) of Nicaragua in 1994 to that in 2000?
Provide a succinct answer. 0.92. What is the ratio of the Exports(as % of merchandise exports) of Central Europe in 1994 to that in 2001?
Offer a terse response. 1.8. What is the ratio of the Exports(as % of merchandise exports) of Argentina in 1994 to that in 2001?
Offer a terse response. 1.17. What is the ratio of the Exports(as % of merchandise exports) of Mozambique in 1994 to that in 2001?
Ensure brevity in your answer.  2.93. What is the ratio of the Exports(as % of merchandise exports) of Nicaragua in 1994 to that in 2001?
Your response must be concise. 0.99. What is the ratio of the Exports(as % of merchandise exports) in Central Europe in 1995 to that in 1996?
Offer a terse response. 0.99. What is the ratio of the Exports(as % of merchandise exports) of Argentina in 1995 to that in 1996?
Make the answer very short. 0.96. What is the ratio of the Exports(as % of merchandise exports) of Mozambique in 1995 to that in 1996?
Offer a very short reply. 0.96. What is the ratio of the Exports(as % of merchandise exports) of Nicaragua in 1995 to that in 1996?
Ensure brevity in your answer.  1.25. What is the ratio of the Exports(as % of merchandise exports) in Central Europe in 1995 to that in 1997?
Ensure brevity in your answer.  1.11. What is the ratio of the Exports(as % of merchandise exports) in Argentina in 1995 to that in 1997?
Keep it short and to the point. 1.02. What is the ratio of the Exports(as % of merchandise exports) of Mozambique in 1995 to that in 1997?
Offer a terse response. 0.92. What is the ratio of the Exports(as % of merchandise exports) of Nicaragua in 1995 to that in 1997?
Your answer should be very brief. 1.08. What is the ratio of the Exports(as % of merchandise exports) in Central Europe in 1995 to that in 1999?
Give a very brief answer. 1.5. What is the ratio of the Exports(as % of merchandise exports) in Argentina in 1995 to that in 1999?
Make the answer very short. 1.01. What is the ratio of the Exports(as % of merchandise exports) of Mozambique in 1995 to that in 1999?
Your response must be concise. 1.27. What is the ratio of the Exports(as % of merchandise exports) in Nicaragua in 1995 to that in 1999?
Offer a very short reply. 0.85. What is the ratio of the Exports(as % of merchandise exports) of Central Europe in 1995 to that in 2000?
Your answer should be compact. 1.77. What is the ratio of the Exports(as % of merchandise exports) of Argentina in 1995 to that in 2000?
Your response must be concise. 1.14. What is the ratio of the Exports(as % of merchandise exports) of Mozambique in 1995 to that in 2000?
Your answer should be compact. 1.59. What is the ratio of the Exports(as % of merchandise exports) of Nicaragua in 1995 to that in 2000?
Provide a short and direct response. 0.85. What is the ratio of the Exports(as % of merchandise exports) of Central Europe in 1995 to that in 2001?
Your answer should be compact. 1.7. What is the ratio of the Exports(as % of merchandise exports) in Argentina in 1995 to that in 2001?
Offer a terse response. 1.12. What is the ratio of the Exports(as % of merchandise exports) in Mozambique in 1995 to that in 2001?
Your answer should be compact. 2.91. What is the ratio of the Exports(as % of merchandise exports) in Nicaragua in 1995 to that in 2001?
Your answer should be very brief. 0.91. What is the ratio of the Exports(as % of merchandise exports) of Central Europe in 1996 to that in 1997?
Your answer should be very brief. 1.12. What is the ratio of the Exports(as % of merchandise exports) in Argentina in 1996 to that in 1997?
Provide a short and direct response. 1.07. What is the ratio of the Exports(as % of merchandise exports) of Mozambique in 1996 to that in 1997?
Give a very brief answer. 0.96. What is the ratio of the Exports(as % of merchandise exports) in Nicaragua in 1996 to that in 1997?
Your response must be concise. 0.86. What is the ratio of the Exports(as % of merchandise exports) in Central Europe in 1996 to that in 1999?
Offer a very short reply. 1.51. What is the ratio of the Exports(as % of merchandise exports) of Argentina in 1996 to that in 1999?
Provide a succinct answer. 1.05. What is the ratio of the Exports(as % of merchandise exports) in Mozambique in 1996 to that in 1999?
Your answer should be compact. 1.32. What is the ratio of the Exports(as % of merchandise exports) of Nicaragua in 1996 to that in 1999?
Your answer should be compact. 0.68. What is the ratio of the Exports(as % of merchandise exports) in Central Europe in 1996 to that in 2000?
Your answer should be very brief. 1.78. What is the ratio of the Exports(as % of merchandise exports) in Argentina in 1996 to that in 2000?
Your response must be concise. 1.19. What is the ratio of the Exports(as % of merchandise exports) in Mozambique in 1996 to that in 2000?
Provide a succinct answer. 1.65. What is the ratio of the Exports(as % of merchandise exports) of Nicaragua in 1996 to that in 2000?
Ensure brevity in your answer.  0.68. What is the ratio of the Exports(as % of merchandise exports) of Central Europe in 1996 to that in 2001?
Ensure brevity in your answer.  1.71. What is the ratio of the Exports(as % of merchandise exports) of Argentina in 1996 to that in 2001?
Offer a very short reply. 1.17. What is the ratio of the Exports(as % of merchandise exports) in Mozambique in 1996 to that in 2001?
Your answer should be very brief. 3.03. What is the ratio of the Exports(as % of merchandise exports) in Nicaragua in 1996 to that in 2001?
Your answer should be very brief. 0.73. What is the ratio of the Exports(as % of merchandise exports) in Central Europe in 1997 to that in 1999?
Make the answer very short. 1.36. What is the ratio of the Exports(as % of merchandise exports) of Argentina in 1997 to that in 1999?
Make the answer very short. 0.98. What is the ratio of the Exports(as % of merchandise exports) of Mozambique in 1997 to that in 1999?
Ensure brevity in your answer.  1.38. What is the ratio of the Exports(as % of merchandise exports) of Nicaragua in 1997 to that in 1999?
Your answer should be compact. 0.79. What is the ratio of the Exports(as % of merchandise exports) in Central Europe in 1997 to that in 2000?
Give a very brief answer. 1.59. What is the ratio of the Exports(as % of merchandise exports) in Argentina in 1997 to that in 2000?
Make the answer very short. 1.11. What is the ratio of the Exports(as % of merchandise exports) of Mozambique in 1997 to that in 2000?
Offer a very short reply. 1.72. What is the ratio of the Exports(as % of merchandise exports) in Nicaragua in 1997 to that in 2000?
Keep it short and to the point. 0.79. What is the ratio of the Exports(as % of merchandise exports) of Central Europe in 1997 to that in 2001?
Give a very brief answer. 1.54. What is the ratio of the Exports(as % of merchandise exports) of Argentina in 1997 to that in 2001?
Your answer should be very brief. 1.09. What is the ratio of the Exports(as % of merchandise exports) in Mozambique in 1997 to that in 2001?
Your answer should be very brief. 3.15. What is the ratio of the Exports(as % of merchandise exports) in Nicaragua in 1997 to that in 2001?
Your answer should be very brief. 0.85. What is the ratio of the Exports(as % of merchandise exports) of Central Europe in 1999 to that in 2000?
Your response must be concise. 1.17. What is the ratio of the Exports(as % of merchandise exports) in Argentina in 1999 to that in 2000?
Provide a succinct answer. 1.13. What is the ratio of the Exports(as % of merchandise exports) in Mozambique in 1999 to that in 2000?
Provide a short and direct response. 1.25. What is the ratio of the Exports(as % of merchandise exports) of Nicaragua in 1999 to that in 2000?
Offer a terse response. 1. What is the ratio of the Exports(as % of merchandise exports) in Central Europe in 1999 to that in 2001?
Give a very brief answer. 1.13. What is the ratio of the Exports(as % of merchandise exports) in Argentina in 1999 to that in 2001?
Make the answer very short. 1.11. What is the ratio of the Exports(as % of merchandise exports) in Mozambique in 1999 to that in 2001?
Offer a terse response. 2.29. What is the ratio of the Exports(as % of merchandise exports) of Nicaragua in 1999 to that in 2001?
Offer a very short reply. 1.07. What is the ratio of the Exports(as % of merchandise exports) of Central Europe in 2000 to that in 2001?
Offer a very short reply. 0.96. What is the ratio of the Exports(as % of merchandise exports) of Argentina in 2000 to that in 2001?
Make the answer very short. 0.99. What is the ratio of the Exports(as % of merchandise exports) of Mozambique in 2000 to that in 2001?
Offer a terse response. 1.84. What is the ratio of the Exports(as % of merchandise exports) of Nicaragua in 2000 to that in 2001?
Provide a succinct answer. 1.07. What is the difference between the highest and the second highest Exports(as % of merchandise exports) in Central Europe?
Provide a succinct answer. 0.57. What is the difference between the highest and the second highest Exports(as % of merchandise exports) of Argentina?
Give a very brief answer. 0.01. What is the difference between the highest and the second highest Exports(as % of merchandise exports) in Mozambique?
Your answer should be very brief. 2.8. What is the difference between the highest and the second highest Exports(as % of merchandise exports) of Nicaragua?
Ensure brevity in your answer.  0.32. What is the difference between the highest and the lowest Exports(as % of merchandise exports) in Central Europe?
Ensure brevity in your answer.  5.32. What is the difference between the highest and the lowest Exports(as % of merchandise exports) in Argentina?
Keep it short and to the point. 8.15. What is the difference between the highest and the lowest Exports(as % of merchandise exports) of Mozambique?
Provide a succinct answer. 48.96. What is the difference between the highest and the lowest Exports(as % of merchandise exports) of Nicaragua?
Provide a succinct answer. 28.07. 